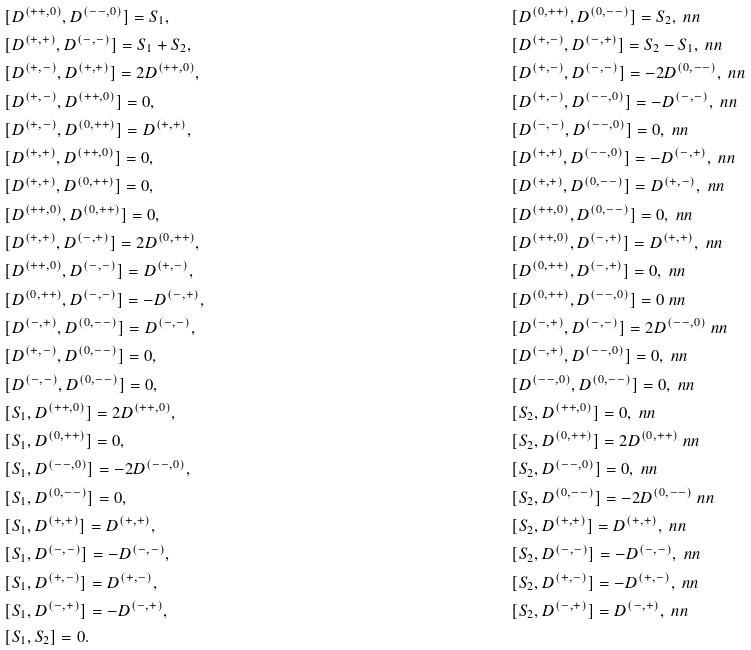<formula> <loc_0><loc_0><loc_500><loc_500>& [ D ^ { ( + + , 0 ) } , D ^ { ( - - , 0 ) } ] = S _ { 1 } , & & [ D ^ { ( 0 , + + ) } , D ^ { ( 0 , - - ) } ] = S _ { 2 } , \ n n \\ & [ D ^ { ( + , + ) } , D ^ { ( - , - ) } ] = S _ { 1 } + S _ { 2 } , & & [ D ^ { ( + , - ) } , D ^ { ( - , + ) } ] = S _ { 2 } - S _ { 1 } , \ n n \\ & [ D ^ { ( + , - ) } , D ^ { ( + , + ) } ] = 2 D ^ { ( + + , 0 ) } , & & [ D ^ { ( + , - ) } , D ^ { ( - , - ) } ] = - 2 D ^ { ( 0 , - - ) } , \ n n \\ & [ D ^ { ( + , - ) } , D ^ { ( + + , 0 ) } ] = 0 , & & [ D ^ { ( + , - ) } , D ^ { ( - - , 0 ) } ] = - D ^ { ( - , - ) } , \ n n \\ & [ D ^ { ( + , - ) } , D ^ { ( 0 , + + ) } ] = D ^ { ( + , + ) } , & & [ D ^ { ( - , - ) } , D ^ { ( - - , 0 ) } ] = 0 , \ n n \\ & [ D ^ { ( + , + ) } , D ^ { ( + + , 0 ) } ] = 0 , & & [ D ^ { ( + , + ) } , D ^ { ( - - , 0 ) } ] = - D ^ { ( - , + ) } , \ n n \\ & [ D ^ { ( + , + ) } , D ^ { ( 0 , + + ) } ] = 0 , & & [ D ^ { ( + , + ) } , D ^ { ( 0 , - - ) } ] = D ^ { ( + , - ) } , \ n n \\ & [ D ^ { ( + + , 0 ) } , D ^ { ( 0 , + + ) } ] = 0 , & & [ D ^ { ( + + , 0 ) } , D ^ { ( 0 , - - ) } ] = 0 , \ n n \\ & [ D ^ { ( + , + ) } , D ^ { ( - , + ) } ] = 2 D ^ { ( 0 , + + ) } , & & [ D ^ { ( + + , 0 ) } , D ^ { ( - , + ) } ] = D ^ { ( + , + ) } , \ n n \\ & [ D ^ { ( + + , 0 ) } , D ^ { ( - , - ) } ] = D ^ { ( + , - ) } , & & [ D ^ { ( 0 , + + ) } , D ^ { ( - , + ) } ] = 0 , \ n n \\ & [ D ^ { ( 0 , + + ) } , D ^ { ( - , - ) } ] = - D ^ { ( - , + ) } , & & [ D ^ { ( 0 , + + ) } , D ^ { ( - - , 0 ) } ] = 0 \ n n \\ & [ D ^ { ( - , + ) } , D ^ { ( 0 , - - ) } ] = D ^ { ( - , - ) } , & & [ D ^ { ( - , + ) } , D ^ { ( - , - ) } ] = 2 D ^ { ( - - , 0 ) } \ n n \\ & [ D ^ { ( + , - ) } , D ^ { ( 0 , - - ) } ] = 0 , & & [ D ^ { ( - , + ) } , D ^ { ( - - , 0 ) } ] = 0 , \ n n \\ & [ D ^ { ( - , - ) } , D ^ { ( 0 , - - ) } ] = 0 , & & [ D ^ { ( - - , 0 ) } , D ^ { ( 0 , - - ) } ] = 0 , \ n n \\ & [ S _ { 1 } , D ^ { ( + + , 0 ) } ] = 2 D ^ { ( + + , 0 ) } , & & [ S _ { 2 } , D ^ { ( + + , 0 ) } ] = 0 , \ n n \\ & [ S _ { 1 } , D ^ { ( 0 , + + ) } ] = 0 , & & [ S _ { 2 } , D ^ { ( 0 , + + ) } ] = 2 D ^ { ( 0 , + + ) } \ n n \\ & [ S _ { 1 } , D ^ { ( - - , 0 ) } ] = - 2 D ^ { ( - - , 0 ) } , & & [ S _ { 2 } , D ^ { ( - - , 0 ) } ] = 0 , \ n n \\ & [ S _ { 1 } , D ^ { ( 0 , - - ) } ] = 0 , & & [ S _ { 2 } , D ^ { ( 0 , - - ) } ] = - 2 D ^ { ( 0 , - - ) } \ n n \\ & [ S _ { 1 } , D ^ { ( + , + ) } ] = D ^ { ( + , + ) } , & & [ S _ { 2 } , D ^ { ( + , + ) } ] = D ^ { ( + , + ) } , \ n n \\ & [ S _ { 1 } , D ^ { ( - , - ) } ] = - D ^ { ( - , - ) } , & & [ S _ { 2 } , D ^ { ( - , - ) } ] = - D ^ { ( - , - ) } , \ n n \\ & [ S _ { 1 } , D ^ { ( + , - ) } ] = D ^ { ( + , - ) } , & & [ S _ { 2 } , D ^ { ( + , - ) } ] = - D ^ { ( + , - ) } , \ n n \\ & [ S _ { 1 } , D ^ { ( - , + ) } ] = - D ^ { ( - , + ) } , & & [ S _ { 2 } , D ^ { ( - , + ) } ] = D ^ { ( - , + ) } , \ n n \\ & [ S _ { 1 } , S _ { 2 } ] = 0 .</formula> 